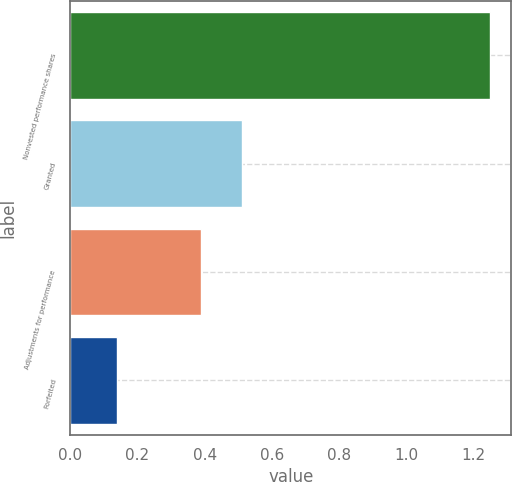Convert chart to OTSL. <chart><loc_0><loc_0><loc_500><loc_500><bar_chart><fcel>Nonvested performance shares<fcel>Granted<fcel>Adjustments for performance<fcel>Forfeited<nl><fcel>1.25<fcel>0.51<fcel>0.39<fcel>0.14<nl></chart> 